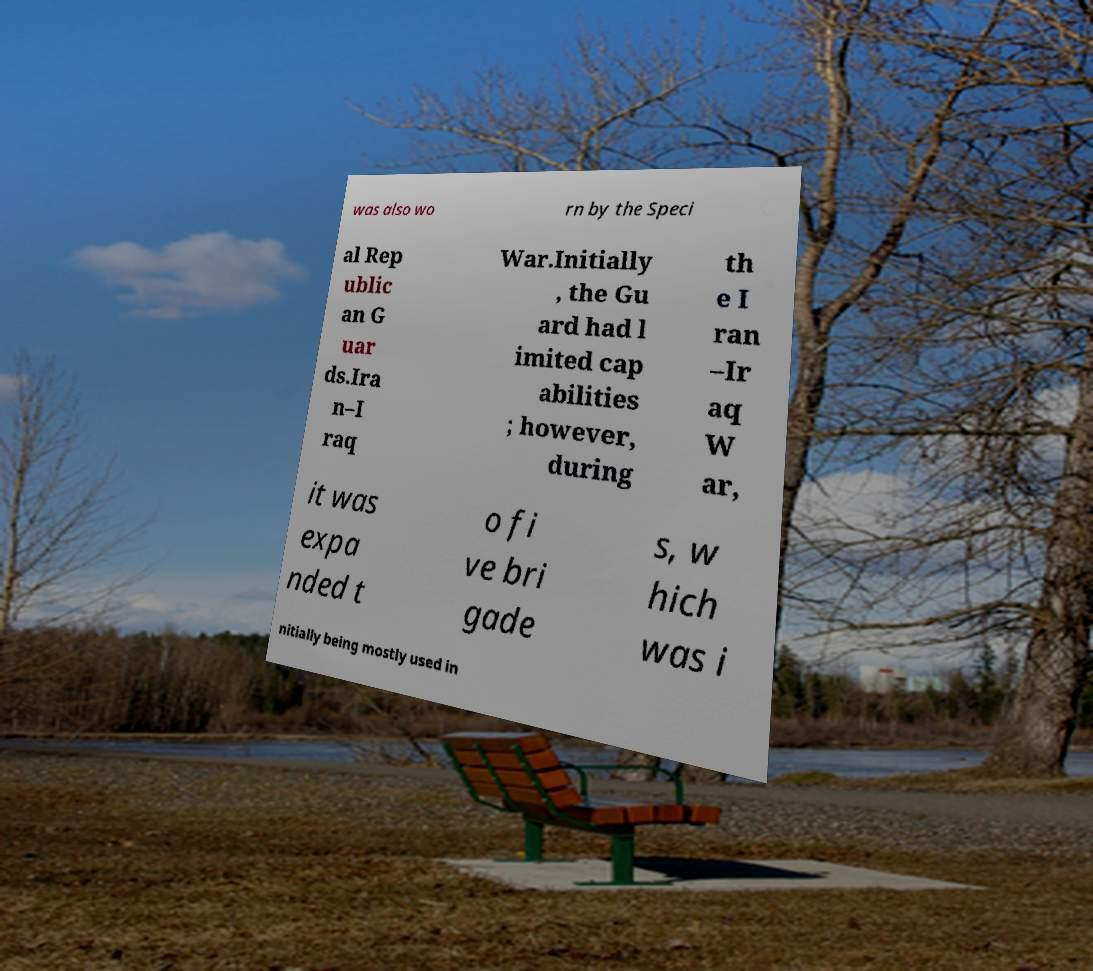Please read and relay the text visible in this image. What does it say? was also wo rn by the Speci al Rep ublic an G uar ds.Ira n–I raq War.Initially , the Gu ard had l imited cap abilities ; however, during th e I ran –Ir aq W ar, it was expa nded t o fi ve bri gade s, w hich was i nitially being mostly used in 